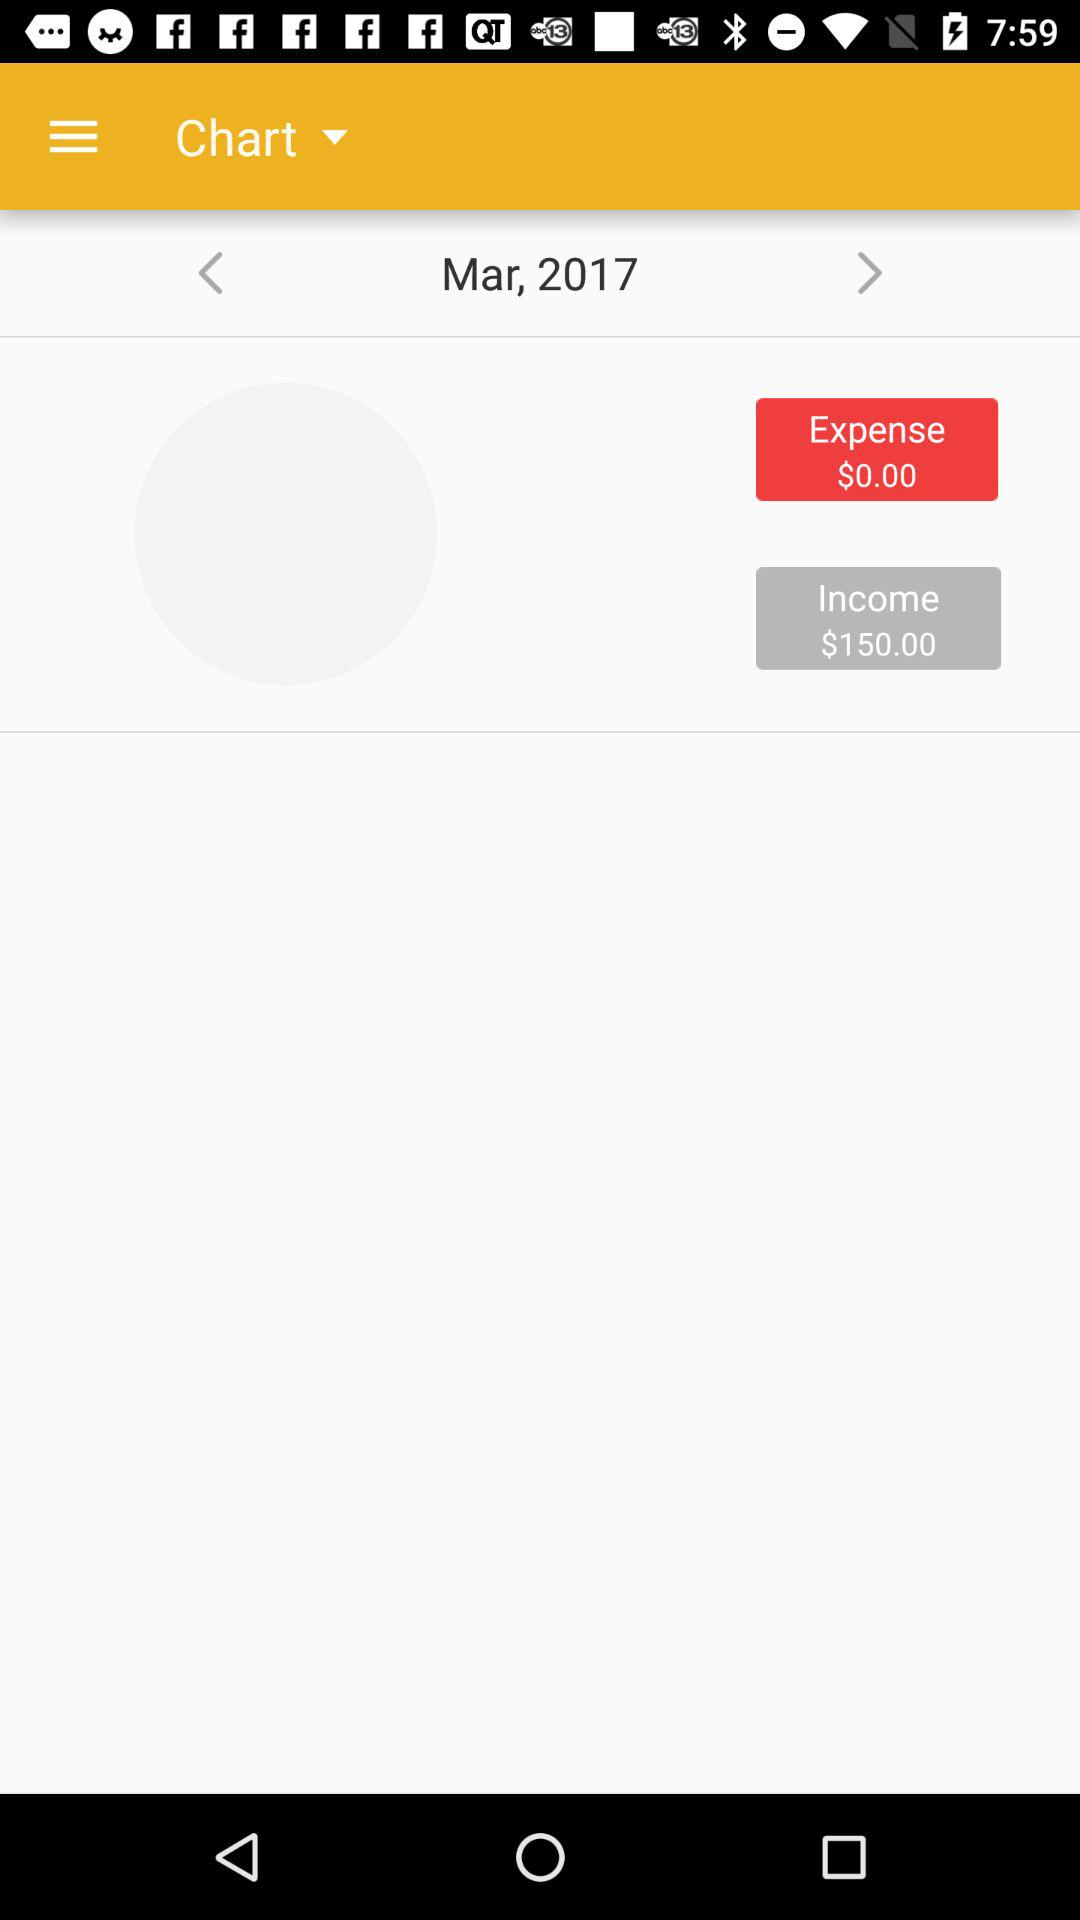How many months are shown in the chart?
Answer the question using a single word or phrase. 1 